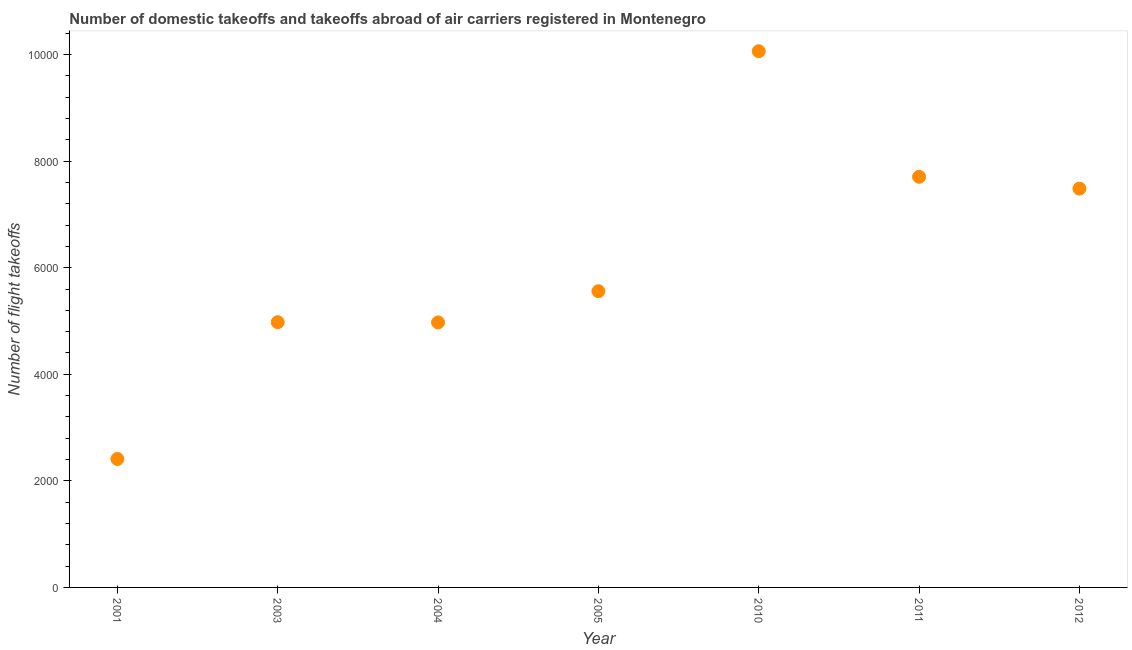What is the number of flight takeoffs in 2005?
Keep it short and to the point. 5560. Across all years, what is the maximum number of flight takeoffs?
Ensure brevity in your answer.  1.01e+04. Across all years, what is the minimum number of flight takeoffs?
Keep it short and to the point. 2411. In which year was the number of flight takeoffs maximum?
Your answer should be very brief. 2010. What is the sum of the number of flight takeoffs?
Keep it short and to the point. 4.32e+04. What is the average number of flight takeoffs per year?
Ensure brevity in your answer.  6168.43. What is the median number of flight takeoffs?
Offer a terse response. 5560. In how many years, is the number of flight takeoffs greater than 6800 ?
Provide a short and direct response. 3. Do a majority of the years between 2003 and 2012 (inclusive) have number of flight takeoffs greater than 3200 ?
Provide a succinct answer. Yes. What is the ratio of the number of flight takeoffs in 2001 to that in 2010?
Offer a very short reply. 0.24. What is the difference between the highest and the second highest number of flight takeoffs?
Ensure brevity in your answer.  2357.01. What is the difference between the highest and the lowest number of flight takeoffs?
Ensure brevity in your answer.  7653.01. How many dotlines are there?
Give a very brief answer. 1. How many years are there in the graph?
Your response must be concise. 7. Are the values on the major ticks of Y-axis written in scientific E-notation?
Make the answer very short. No. Does the graph contain any zero values?
Provide a succinct answer. No. What is the title of the graph?
Offer a very short reply. Number of domestic takeoffs and takeoffs abroad of air carriers registered in Montenegro. What is the label or title of the X-axis?
Your answer should be very brief. Year. What is the label or title of the Y-axis?
Your response must be concise. Number of flight takeoffs. What is the Number of flight takeoffs in 2001?
Give a very brief answer. 2411. What is the Number of flight takeoffs in 2003?
Offer a very short reply. 4978. What is the Number of flight takeoffs in 2004?
Your answer should be compact. 4974. What is the Number of flight takeoffs in 2005?
Your answer should be very brief. 5560. What is the Number of flight takeoffs in 2010?
Give a very brief answer. 1.01e+04. What is the Number of flight takeoffs in 2011?
Keep it short and to the point. 7707. What is the Number of flight takeoffs in 2012?
Ensure brevity in your answer.  7485. What is the difference between the Number of flight takeoffs in 2001 and 2003?
Your answer should be compact. -2567. What is the difference between the Number of flight takeoffs in 2001 and 2004?
Keep it short and to the point. -2563. What is the difference between the Number of flight takeoffs in 2001 and 2005?
Your answer should be very brief. -3149. What is the difference between the Number of flight takeoffs in 2001 and 2010?
Offer a very short reply. -7653.01. What is the difference between the Number of flight takeoffs in 2001 and 2011?
Ensure brevity in your answer.  -5296. What is the difference between the Number of flight takeoffs in 2001 and 2012?
Your answer should be compact. -5074. What is the difference between the Number of flight takeoffs in 2003 and 2004?
Provide a short and direct response. 4. What is the difference between the Number of flight takeoffs in 2003 and 2005?
Offer a very short reply. -582. What is the difference between the Number of flight takeoffs in 2003 and 2010?
Provide a short and direct response. -5086.01. What is the difference between the Number of flight takeoffs in 2003 and 2011?
Give a very brief answer. -2729. What is the difference between the Number of flight takeoffs in 2003 and 2012?
Make the answer very short. -2507. What is the difference between the Number of flight takeoffs in 2004 and 2005?
Your answer should be very brief. -586. What is the difference between the Number of flight takeoffs in 2004 and 2010?
Make the answer very short. -5090.01. What is the difference between the Number of flight takeoffs in 2004 and 2011?
Give a very brief answer. -2733. What is the difference between the Number of flight takeoffs in 2004 and 2012?
Provide a short and direct response. -2511. What is the difference between the Number of flight takeoffs in 2005 and 2010?
Your answer should be very brief. -4504.01. What is the difference between the Number of flight takeoffs in 2005 and 2011?
Make the answer very short. -2147. What is the difference between the Number of flight takeoffs in 2005 and 2012?
Your answer should be very brief. -1925. What is the difference between the Number of flight takeoffs in 2010 and 2011?
Keep it short and to the point. 2357.01. What is the difference between the Number of flight takeoffs in 2010 and 2012?
Your answer should be very brief. 2579.01. What is the difference between the Number of flight takeoffs in 2011 and 2012?
Provide a succinct answer. 222. What is the ratio of the Number of flight takeoffs in 2001 to that in 2003?
Your answer should be very brief. 0.48. What is the ratio of the Number of flight takeoffs in 2001 to that in 2004?
Your answer should be compact. 0.48. What is the ratio of the Number of flight takeoffs in 2001 to that in 2005?
Give a very brief answer. 0.43. What is the ratio of the Number of flight takeoffs in 2001 to that in 2010?
Ensure brevity in your answer.  0.24. What is the ratio of the Number of flight takeoffs in 2001 to that in 2011?
Provide a short and direct response. 0.31. What is the ratio of the Number of flight takeoffs in 2001 to that in 2012?
Make the answer very short. 0.32. What is the ratio of the Number of flight takeoffs in 2003 to that in 2005?
Your answer should be very brief. 0.9. What is the ratio of the Number of flight takeoffs in 2003 to that in 2010?
Make the answer very short. 0.49. What is the ratio of the Number of flight takeoffs in 2003 to that in 2011?
Give a very brief answer. 0.65. What is the ratio of the Number of flight takeoffs in 2003 to that in 2012?
Provide a short and direct response. 0.67. What is the ratio of the Number of flight takeoffs in 2004 to that in 2005?
Offer a very short reply. 0.9. What is the ratio of the Number of flight takeoffs in 2004 to that in 2010?
Ensure brevity in your answer.  0.49. What is the ratio of the Number of flight takeoffs in 2004 to that in 2011?
Your answer should be compact. 0.65. What is the ratio of the Number of flight takeoffs in 2004 to that in 2012?
Make the answer very short. 0.67. What is the ratio of the Number of flight takeoffs in 2005 to that in 2010?
Your answer should be very brief. 0.55. What is the ratio of the Number of flight takeoffs in 2005 to that in 2011?
Ensure brevity in your answer.  0.72. What is the ratio of the Number of flight takeoffs in 2005 to that in 2012?
Offer a terse response. 0.74. What is the ratio of the Number of flight takeoffs in 2010 to that in 2011?
Provide a succinct answer. 1.31. What is the ratio of the Number of flight takeoffs in 2010 to that in 2012?
Offer a very short reply. 1.34. What is the ratio of the Number of flight takeoffs in 2011 to that in 2012?
Your answer should be very brief. 1.03. 